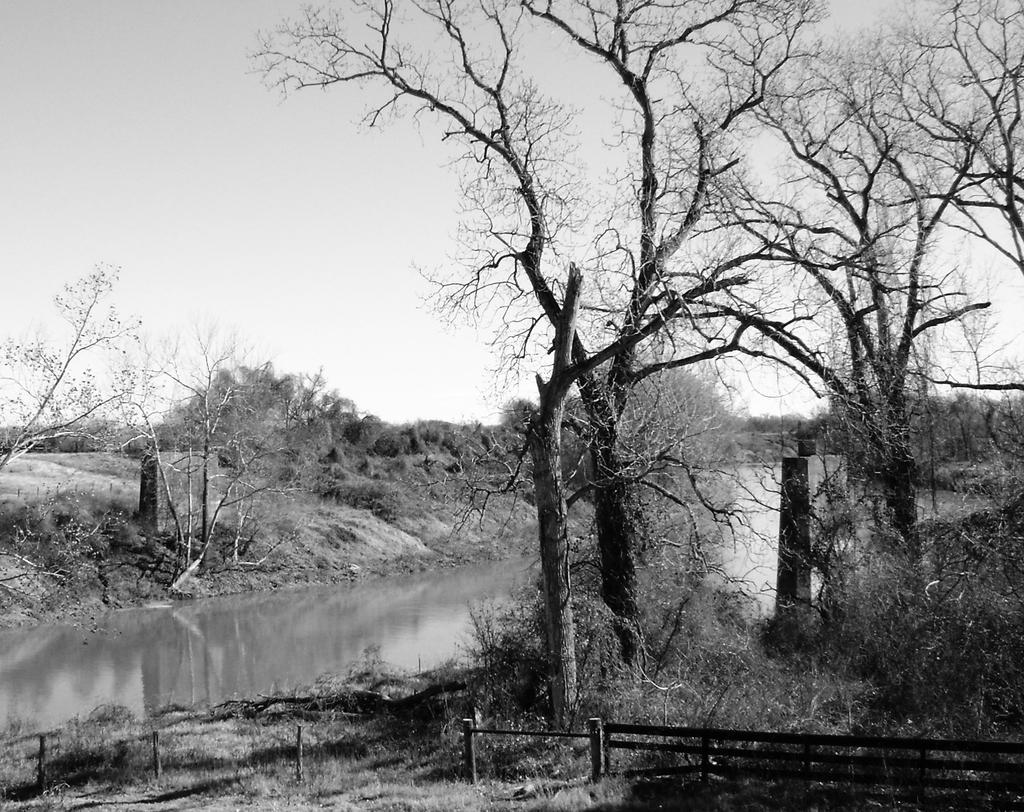How would you summarize this image in a sentence or two? In this black and white picture we can see a river surrounded by trees, bushes & plants. 